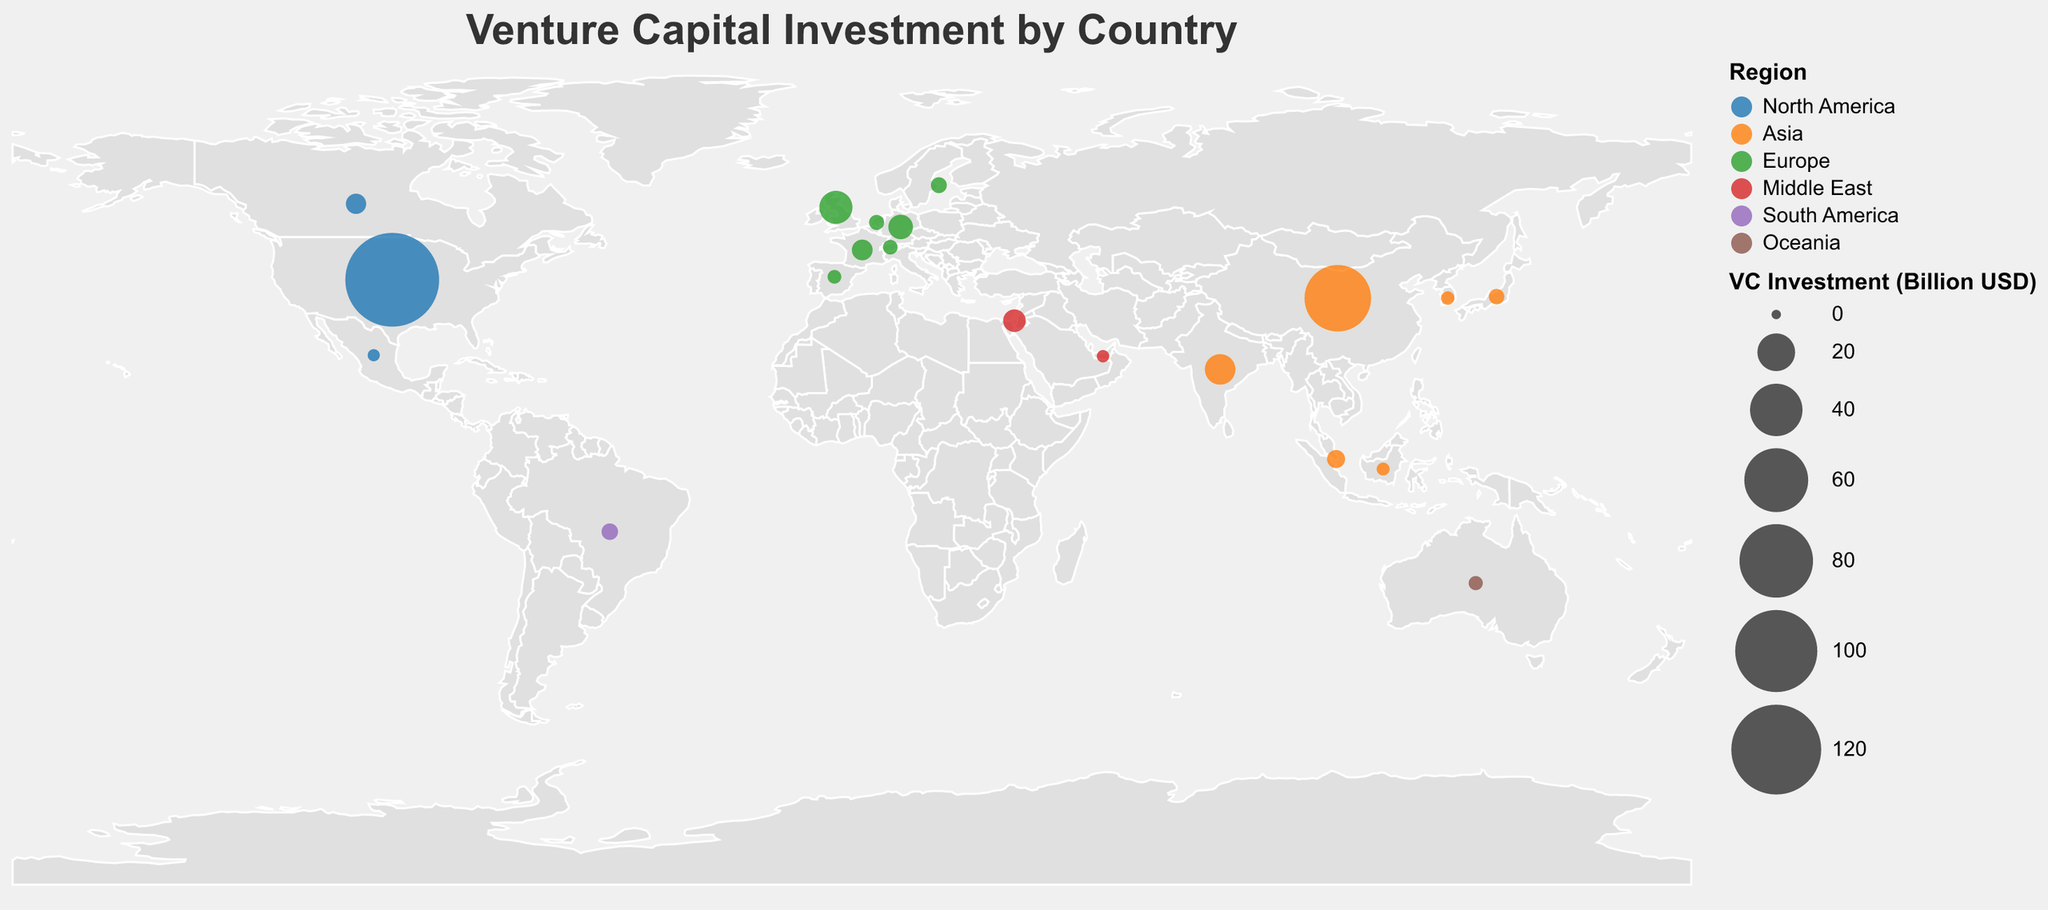What is the total venture capital investment in the United States? The figure uses circle size to represent venture capital investment amounts. According to the tooltip, the total investment in the United States is directly listed.
Answer: 130.9 Billion USD Which country in Asia has the highest venture capital investment? Among the countries in Asia, we look for the circle with the largest size. The tooltip shows that China has the highest value.
Answer: China How many countries in Europe have venture capital investments above 5 billion USD? We identify the countries in Europe and then check the tooltip values alongside their positions.
Europe countries: United Kingdom, Germany, France, Sweden, Netherlands, Switzerland, Spain
The ones above 5 billion USD are the United Kingdom, Germany, and France.
Answer: 3 Compare the venture capital investments between India and Germany. Which one is higher, and by how much? According to the tooltip, India has an investment of 12.7 billion USD, and Germany has 7.8 billion USD. The difference is calculated as 12.7 - 7.8 = 4.9 billion USD, with India having a higher value.
Answer: India by 4.9 Billion USD Which region has the most diverse range of countries receiving venture capital investments? By examining the color-coded regions and the number of countries within each, we find Europe (green) has the highest number of countries listed.
Answer: Europe What is the average venture capital investment in Asian countries? We add up the investments of Asian countries (65.2 + 12.7 + 3.6 + 2.3 + 1.4 + 1.2) and divide by the number of countries (6) to get the average: (65.2 + 12.7 + 3.6 + 2.3 + 1.4 + 1.2) / 6 = 14.4 billion USD
Answer: 14.4 Billion USD Which country in North America except the United States has the highest venture capital investment? Excluding the United States, we look at the North American countries based on the tooltip values. Canada has the highest value in North America after the United States.
Answer: Canada What continent has the lowest venture capital investment overall? By summing up investments in each continent, Oceania has only one country (Australia) with an investment of 1.7 billion USD, making it the lowest.
Answer: Oceania What is the combined venture capital investment of the Middle East countries? Sum the investments of Israel (6.4 billion USD) and the United Arab Emirates (1.0 billion USD): 6.4 + 1 = 7.4 billion USD
Answer: 7.4 Billion USD 